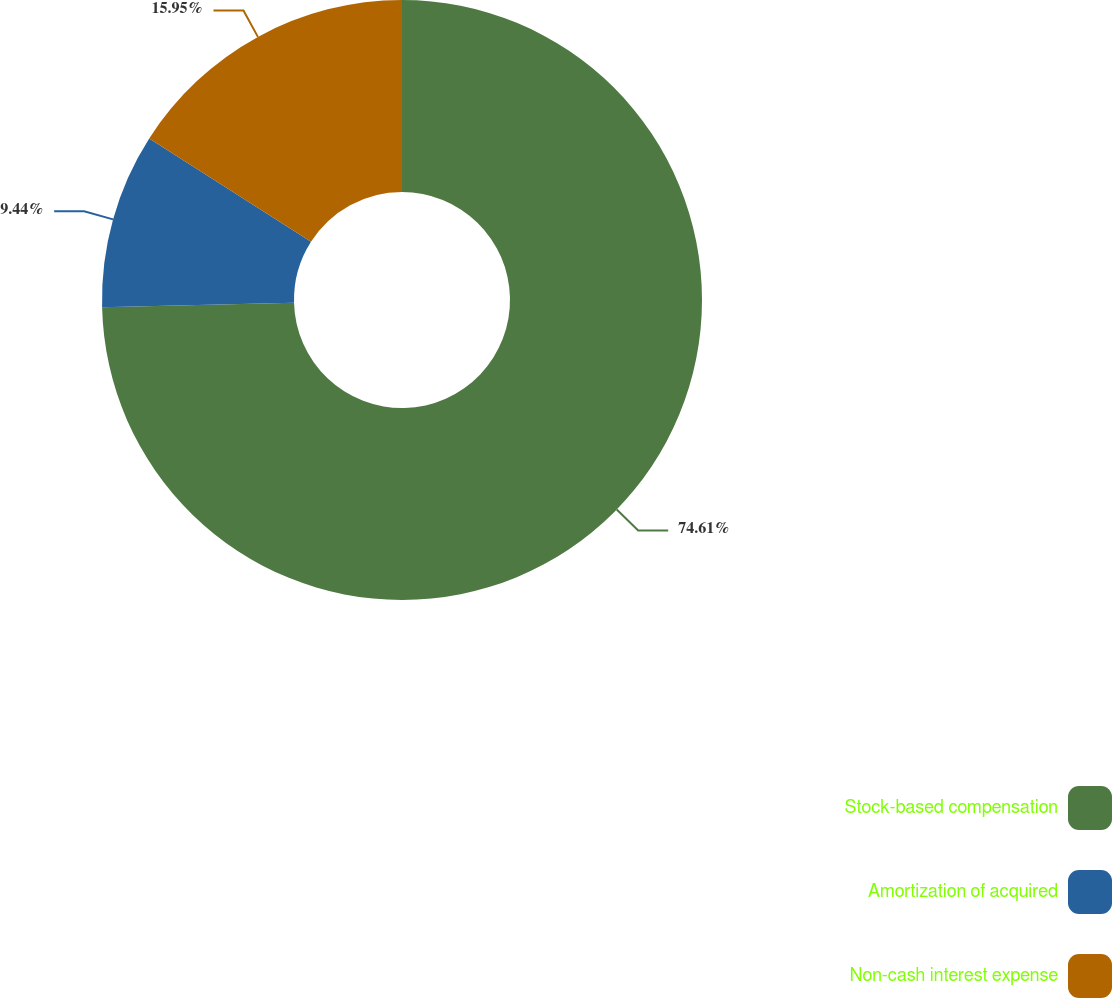Convert chart. <chart><loc_0><loc_0><loc_500><loc_500><pie_chart><fcel>Stock-based compensation<fcel>Amortization of acquired<fcel>Non-cash interest expense<nl><fcel>74.61%<fcel>9.44%<fcel>15.95%<nl></chart> 